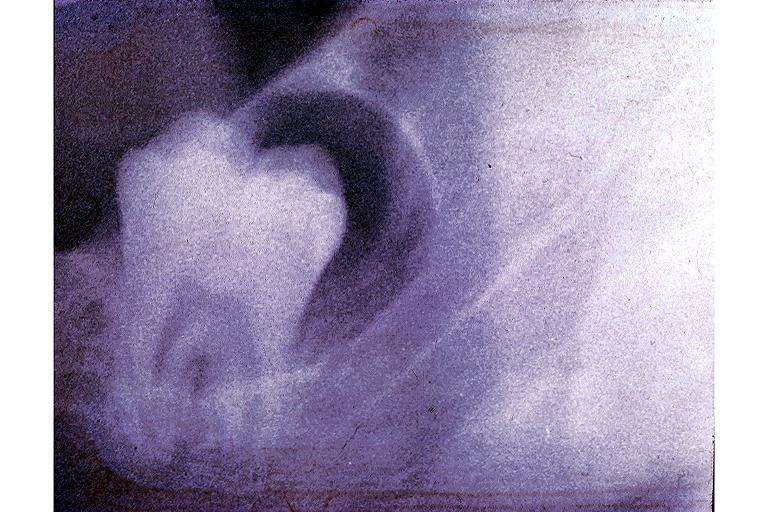s di george syndrome present?
Answer the question using a single word or phrase. No 